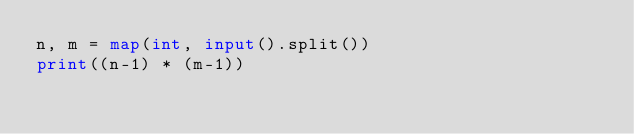<code> <loc_0><loc_0><loc_500><loc_500><_Python_>n, m = map(int, input().split())
print((n-1) * (m-1))</code> 